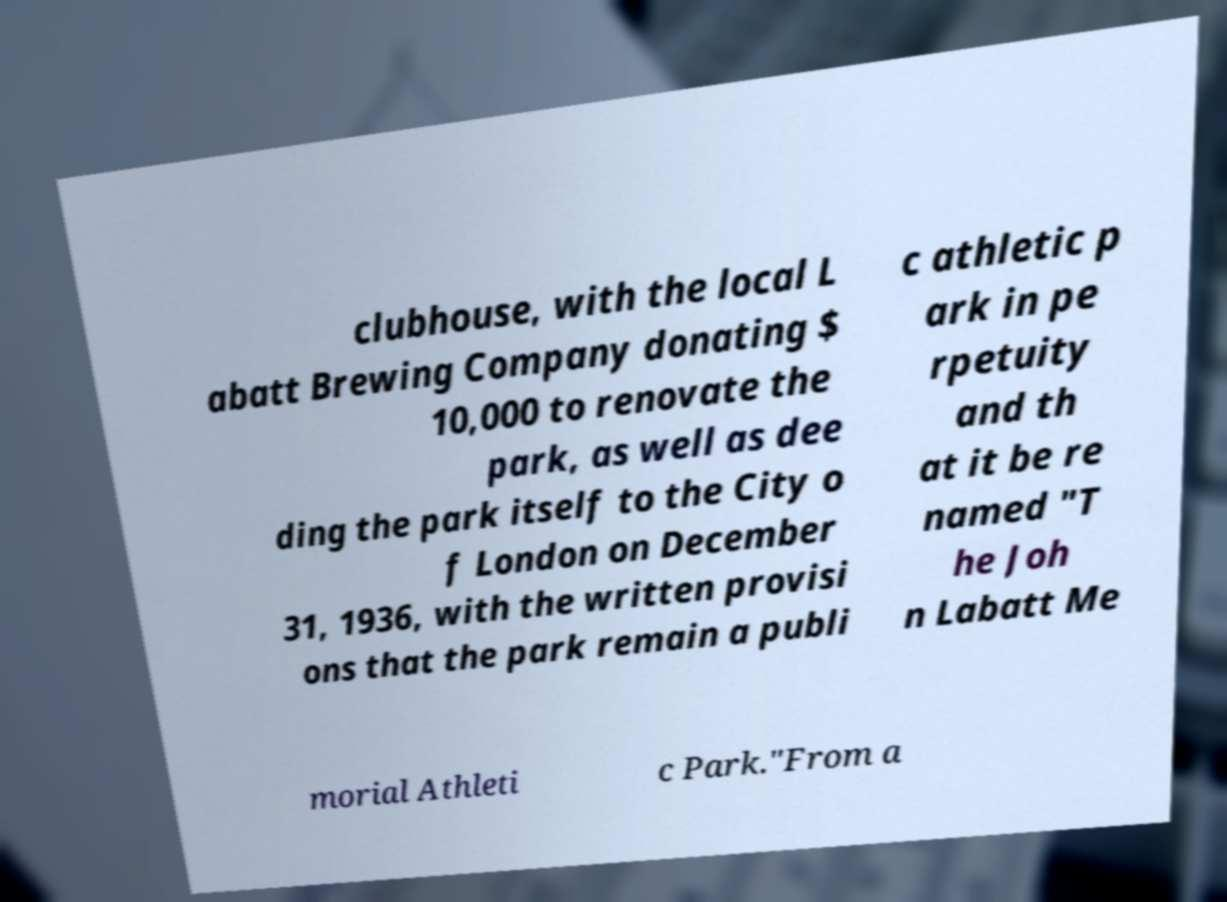Can you accurately transcribe the text from the provided image for me? clubhouse, with the local L abatt Brewing Company donating $ 10,000 to renovate the park, as well as dee ding the park itself to the City o f London on December 31, 1936, with the written provisi ons that the park remain a publi c athletic p ark in pe rpetuity and th at it be re named "T he Joh n Labatt Me morial Athleti c Park."From a 